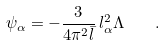<formula> <loc_0><loc_0><loc_500><loc_500>\psi _ { \alpha } = - \frac { 3 } { 4 \pi ^ { 2 } \bar { l } } \, l _ { \alpha } ^ { 2 } \Lambda \quad .</formula> 